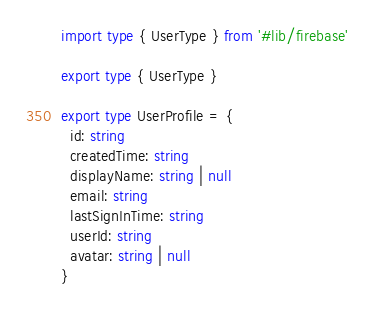Convert code to text. <code><loc_0><loc_0><loc_500><loc_500><_TypeScript_>import type { UserType } from '#lib/firebase'

export type { UserType }

export type UserProfile = {
  id: string
  createdTime: string
  displayName: string | null
  email: string
  lastSignInTime: string
  userId: string
  avatar: string | null
}
</code> 